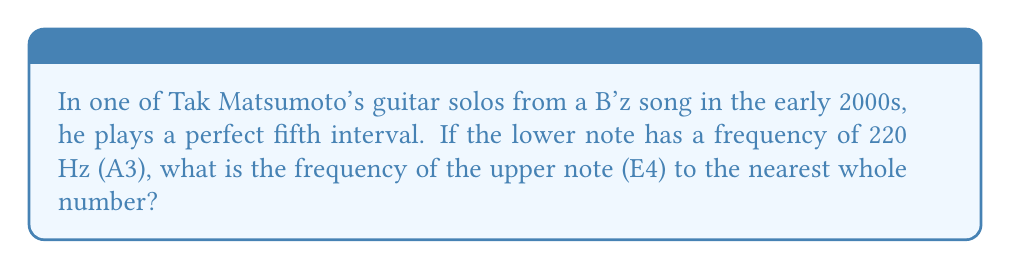Help me with this question. To solve this problem, we need to understand the relationship between musical intervals and frequency ratios:

1. A perfect fifth interval has a frequency ratio of 3:2.

2. Let's denote the frequency of the lower note (A3) as $f_1$ and the upper note (E4) as $f_2$.

3. We can express their relationship as:

   $$\frac{f_2}{f_1} = \frac{3}{2}$$

4. We know that $f_1 = 220$ Hz, so we can substitute this:

   $$\frac{f_2}{220} = \frac{3}{2}$$

5. To solve for $f_2$, multiply both sides by 220:

   $$f_2 = 220 \cdot \frac{3}{2} = 330$$

6. Therefore, the frequency of the upper note (E4) is 330 Hz.
Answer: 330 Hz 